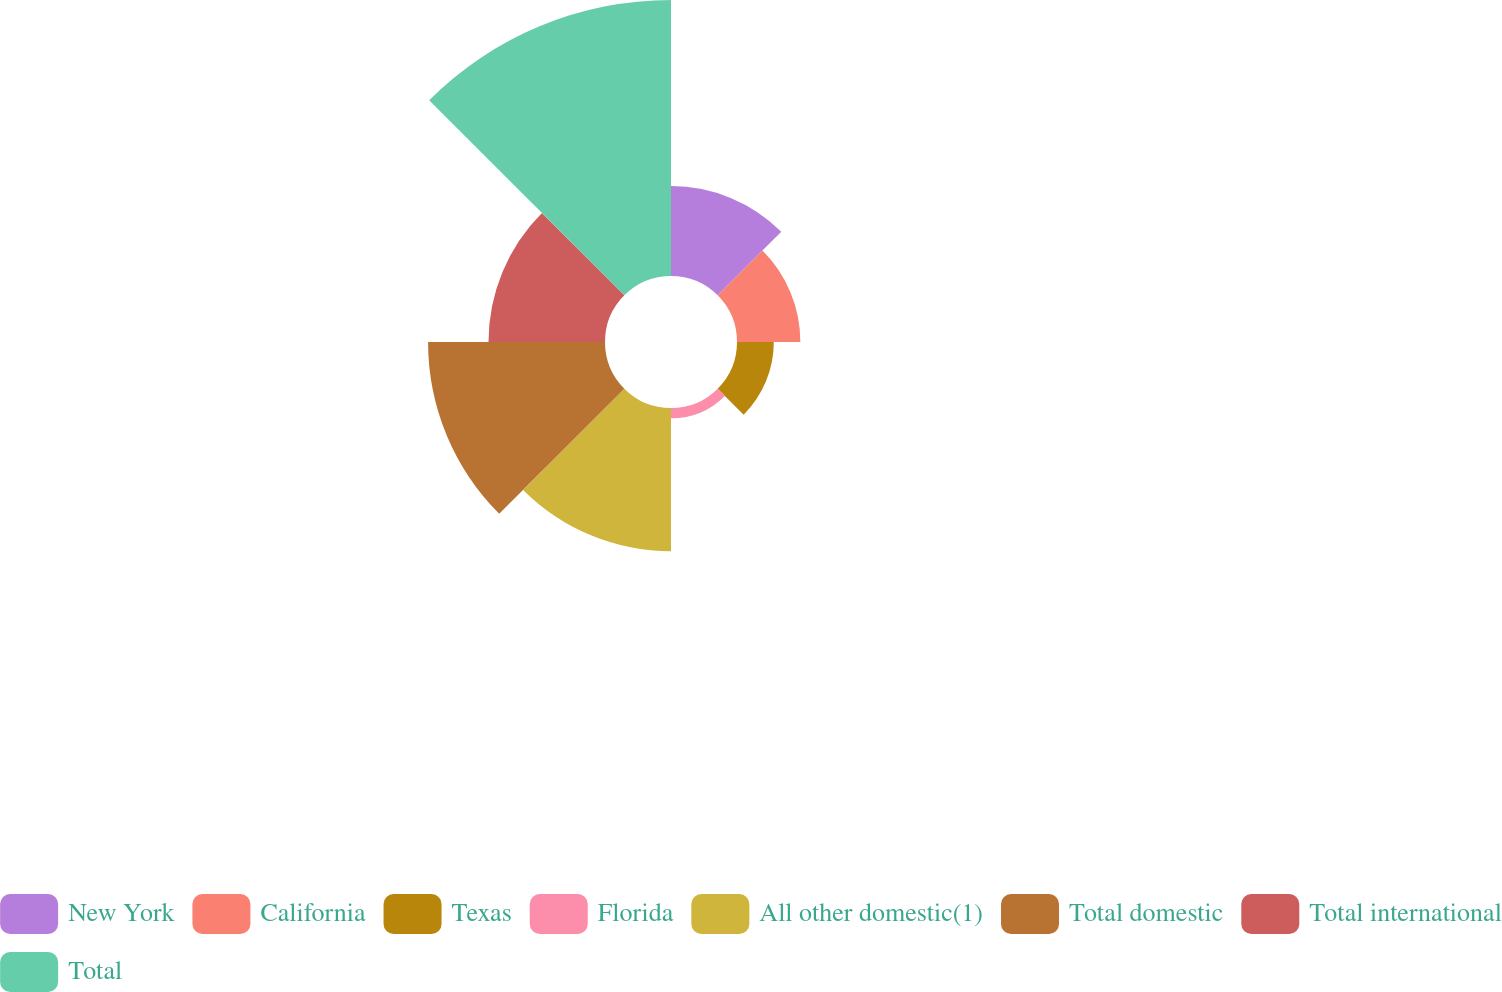<chart> <loc_0><loc_0><loc_500><loc_500><pie_chart><fcel>New York<fcel>California<fcel>Texas<fcel>Florida<fcel>All other domestic(1)<fcel>Total domestic<fcel>Total international<fcel>Total<nl><fcel>9.85%<fcel>6.94%<fcel>4.03%<fcel>1.12%<fcel>15.68%<fcel>19.38%<fcel>12.76%<fcel>30.23%<nl></chart> 